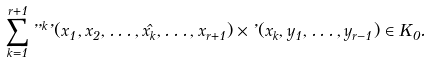<formula> <loc_0><loc_0><loc_500><loc_500>\sum _ { k = 1 } ^ { r + 1 } \varepsilon ^ { k } \varphi ( x _ { 1 } , x _ { 2 } , \dots , \hat { x _ { k } } , \dots , x _ { r + 1 } ) \times \varphi ( x _ { k } , y _ { 1 } , \dots , y _ { r - 1 } ) \in K _ { 0 } .</formula> 